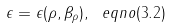<formula> <loc_0><loc_0><loc_500><loc_500>\epsilon = \epsilon ( \rho , \beta _ { \rho } ) , \ e q n o ( 3 . 2 )</formula> 